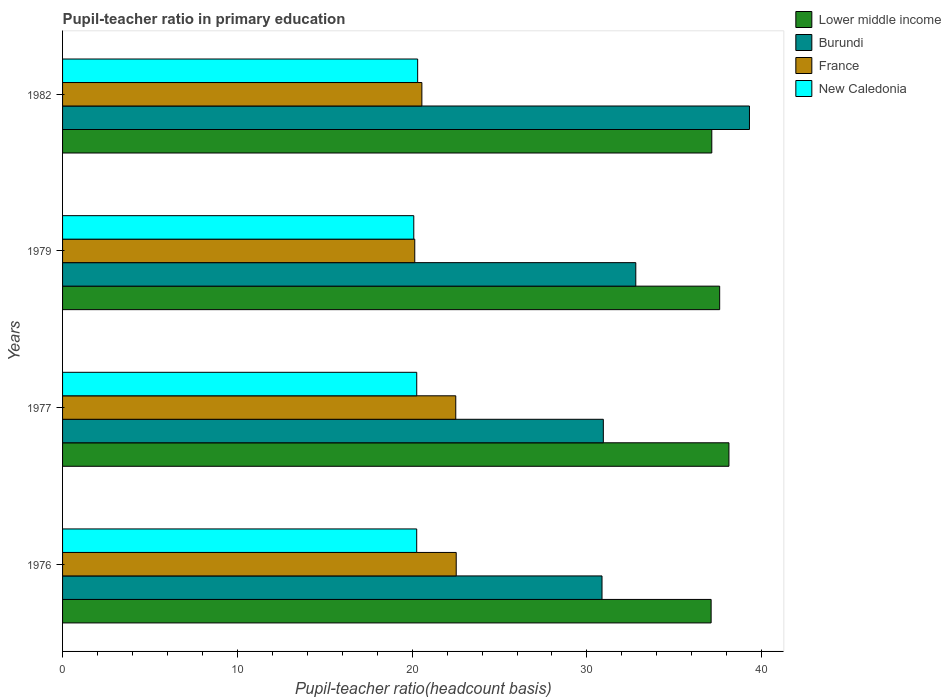How many different coloured bars are there?
Your answer should be very brief. 4. How many groups of bars are there?
Give a very brief answer. 4. Are the number of bars per tick equal to the number of legend labels?
Offer a terse response. Yes. How many bars are there on the 1st tick from the top?
Offer a terse response. 4. How many bars are there on the 4th tick from the bottom?
Offer a terse response. 4. In how many cases, is the number of bars for a given year not equal to the number of legend labels?
Keep it short and to the point. 0. What is the pupil-teacher ratio in primary education in France in 1979?
Your response must be concise. 20.15. Across all years, what is the maximum pupil-teacher ratio in primary education in Burundi?
Provide a short and direct response. 39.3. Across all years, what is the minimum pupil-teacher ratio in primary education in Lower middle income?
Keep it short and to the point. 37.11. In which year was the pupil-teacher ratio in primary education in New Caledonia maximum?
Your response must be concise. 1982. In which year was the pupil-teacher ratio in primary education in Lower middle income minimum?
Provide a short and direct response. 1976. What is the total pupil-teacher ratio in primary education in Lower middle income in the graph?
Provide a succinct answer. 149.97. What is the difference between the pupil-teacher ratio in primary education in Burundi in 1979 and that in 1982?
Make the answer very short. -6.5. What is the difference between the pupil-teacher ratio in primary education in New Caledonia in 1977 and the pupil-teacher ratio in primary education in Burundi in 1982?
Your answer should be compact. -19.04. What is the average pupil-teacher ratio in primary education in New Caledonia per year?
Your answer should be compact. 20.23. In the year 1977, what is the difference between the pupil-teacher ratio in primary education in Burundi and pupil-teacher ratio in primary education in France?
Your answer should be very brief. 8.44. In how many years, is the pupil-teacher ratio in primary education in France greater than 4 ?
Provide a short and direct response. 4. What is the ratio of the pupil-teacher ratio in primary education in Burundi in 1976 to that in 1979?
Your answer should be very brief. 0.94. Is the pupil-teacher ratio in primary education in Burundi in 1977 less than that in 1982?
Offer a very short reply. Yes. Is the difference between the pupil-teacher ratio in primary education in Burundi in 1976 and 1977 greater than the difference between the pupil-teacher ratio in primary education in France in 1976 and 1977?
Your answer should be compact. No. What is the difference between the highest and the second highest pupil-teacher ratio in primary education in Burundi?
Your response must be concise. 6.5. What is the difference between the highest and the lowest pupil-teacher ratio in primary education in Lower middle income?
Your answer should be compact. 1.02. In how many years, is the pupil-teacher ratio in primary education in Lower middle income greater than the average pupil-teacher ratio in primary education in Lower middle income taken over all years?
Provide a succinct answer. 2. What does the 4th bar from the top in 1982 represents?
Your answer should be very brief. Lower middle income. What does the 4th bar from the bottom in 1977 represents?
Keep it short and to the point. New Caledonia. Are all the bars in the graph horizontal?
Give a very brief answer. Yes. What is the difference between two consecutive major ticks on the X-axis?
Provide a succinct answer. 10. Are the values on the major ticks of X-axis written in scientific E-notation?
Offer a terse response. No. Does the graph contain grids?
Provide a succinct answer. No. Where does the legend appear in the graph?
Make the answer very short. Top right. How are the legend labels stacked?
Offer a very short reply. Vertical. What is the title of the graph?
Your answer should be compact. Pupil-teacher ratio in primary education. What is the label or title of the X-axis?
Give a very brief answer. Pupil-teacher ratio(headcount basis). What is the Pupil-teacher ratio(headcount basis) in Lower middle income in 1976?
Ensure brevity in your answer.  37.11. What is the Pupil-teacher ratio(headcount basis) in Burundi in 1976?
Offer a terse response. 30.86. What is the Pupil-teacher ratio(headcount basis) in France in 1976?
Your response must be concise. 22.52. What is the Pupil-teacher ratio(headcount basis) of New Caledonia in 1976?
Your response must be concise. 20.26. What is the Pupil-teacher ratio(headcount basis) of Lower middle income in 1977?
Your answer should be very brief. 38.13. What is the Pupil-teacher ratio(headcount basis) in Burundi in 1977?
Offer a very short reply. 30.94. What is the Pupil-teacher ratio(headcount basis) of France in 1977?
Your answer should be compact. 22.5. What is the Pupil-teacher ratio(headcount basis) of New Caledonia in 1977?
Ensure brevity in your answer.  20.26. What is the Pupil-teacher ratio(headcount basis) of Lower middle income in 1979?
Provide a succinct answer. 37.6. What is the Pupil-teacher ratio(headcount basis) in Burundi in 1979?
Give a very brief answer. 32.8. What is the Pupil-teacher ratio(headcount basis) in France in 1979?
Your response must be concise. 20.15. What is the Pupil-teacher ratio(headcount basis) of New Caledonia in 1979?
Provide a succinct answer. 20.09. What is the Pupil-teacher ratio(headcount basis) of Lower middle income in 1982?
Keep it short and to the point. 37.14. What is the Pupil-teacher ratio(headcount basis) in Burundi in 1982?
Your answer should be very brief. 39.3. What is the Pupil-teacher ratio(headcount basis) of France in 1982?
Keep it short and to the point. 20.56. What is the Pupil-teacher ratio(headcount basis) of New Caledonia in 1982?
Give a very brief answer. 20.32. Across all years, what is the maximum Pupil-teacher ratio(headcount basis) of Lower middle income?
Offer a very short reply. 38.13. Across all years, what is the maximum Pupil-teacher ratio(headcount basis) of Burundi?
Make the answer very short. 39.3. Across all years, what is the maximum Pupil-teacher ratio(headcount basis) of France?
Provide a short and direct response. 22.52. Across all years, what is the maximum Pupil-teacher ratio(headcount basis) of New Caledonia?
Your answer should be compact. 20.32. Across all years, what is the minimum Pupil-teacher ratio(headcount basis) of Lower middle income?
Provide a short and direct response. 37.11. Across all years, what is the minimum Pupil-teacher ratio(headcount basis) in Burundi?
Your response must be concise. 30.86. Across all years, what is the minimum Pupil-teacher ratio(headcount basis) in France?
Offer a terse response. 20.15. Across all years, what is the minimum Pupil-teacher ratio(headcount basis) of New Caledonia?
Your answer should be compact. 20.09. What is the total Pupil-teacher ratio(headcount basis) of Lower middle income in the graph?
Make the answer very short. 149.97. What is the total Pupil-teacher ratio(headcount basis) in Burundi in the graph?
Provide a short and direct response. 133.9. What is the total Pupil-teacher ratio(headcount basis) in France in the graph?
Provide a short and direct response. 85.73. What is the total Pupil-teacher ratio(headcount basis) of New Caledonia in the graph?
Provide a short and direct response. 80.94. What is the difference between the Pupil-teacher ratio(headcount basis) of Lower middle income in 1976 and that in 1977?
Provide a short and direct response. -1.02. What is the difference between the Pupil-teacher ratio(headcount basis) in Burundi in 1976 and that in 1977?
Your response must be concise. -0.08. What is the difference between the Pupil-teacher ratio(headcount basis) in France in 1976 and that in 1977?
Make the answer very short. 0.03. What is the difference between the Pupil-teacher ratio(headcount basis) in New Caledonia in 1976 and that in 1977?
Ensure brevity in your answer.  -0. What is the difference between the Pupil-teacher ratio(headcount basis) in Lower middle income in 1976 and that in 1979?
Keep it short and to the point. -0.49. What is the difference between the Pupil-teacher ratio(headcount basis) of Burundi in 1976 and that in 1979?
Your answer should be very brief. -1.93. What is the difference between the Pupil-teacher ratio(headcount basis) of France in 1976 and that in 1979?
Offer a terse response. 2.37. What is the difference between the Pupil-teacher ratio(headcount basis) of New Caledonia in 1976 and that in 1979?
Give a very brief answer. 0.17. What is the difference between the Pupil-teacher ratio(headcount basis) in Lower middle income in 1976 and that in 1982?
Provide a succinct answer. -0.04. What is the difference between the Pupil-teacher ratio(headcount basis) of Burundi in 1976 and that in 1982?
Offer a terse response. -8.44. What is the difference between the Pupil-teacher ratio(headcount basis) in France in 1976 and that in 1982?
Your answer should be compact. 1.96. What is the difference between the Pupil-teacher ratio(headcount basis) in New Caledonia in 1976 and that in 1982?
Offer a very short reply. -0.05. What is the difference between the Pupil-teacher ratio(headcount basis) in Lower middle income in 1977 and that in 1979?
Keep it short and to the point. 0.53. What is the difference between the Pupil-teacher ratio(headcount basis) in Burundi in 1977 and that in 1979?
Provide a short and direct response. -1.86. What is the difference between the Pupil-teacher ratio(headcount basis) in France in 1977 and that in 1979?
Make the answer very short. 2.35. What is the difference between the Pupil-teacher ratio(headcount basis) of New Caledonia in 1977 and that in 1979?
Offer a very short reply. 0.17. What is the difference between the Pupil-teacher ratio(headcount basis) of Lower middle income in 1977 and that in 1982?
Make the answer very short. 0.98. What is the difference between the Pupil-teacher ratio(headcount basis) of Burundi in 1977 and that in 1982?
Ensure brevity in your answer.  -8.36. What is the difference between the Pupil-teacher ratio(headcount basis) of France in 1977 and that in 1982?
Keep it short and to the point. 1.94. What is the difference between the Pupil-teacher ratio(headcount basis) in New Caledonia in 1977 and that in 1982?
Offer a terse response. -0.05. What is the difference between the Pupil-teacher ratio(headcount basis) of Lower middle income in 1979 and that in 1982?
Offer a terse response. 0.45. What is the difference between the Pupil-teacher ratio(headcount basis) in Burundi in 1979 and that in 1982?
Give a very brief answer. -6.5. What is the difference between the Pupil-teacher ratio(headcount basis) of France in 1979 and that in 1982?
Keep it short and to the point. -0.41. What is the difference between the Pupil-teacher ratio(headcount basis) of New Caledonia in 1979 and that in 1982?
Offer a terse response. -0.22. What is the difference between the Pupil-teacher ratio(headcount basis) in Lower middle income in 1976 and the Pupil-teacher ratio(headcount basis) in Burundi in 1977?
Offer a very short reply. 6.17. What is the difference between the Pupil-teacher ratio(headcount basis) of Lower middle income in 1976 and the Pupil-teacher ratio(headcount basis) of France in 1977?
Provide a short and direct response. 14.61. What is the difference between the Pupil-teacher ratio(headcount basis) of Lower middle income in 1976 and the Pupil-teacher ratio(headcount basis) of New Caledonia in 1977?
Keep it short and to the point. 16.84. What is the difference between the Pupil-teacher ratio(headcount basis) of Burundi in 1976 and the Pupil-teacher ratio(headcount basis) of France in 1977?
Your answer should be very brief. 8.37. What is the difference between the Pupil-teacher ratio(headcount basis) of Burundi in 1976 and the Pupil-teacher ratio(headcount basis) of New Caledonia in 1977?
Your answer should be compact. 10.6. What is the difference between the Pupil-teacher ratio(headcount basis) in France in 1976 and the Pupil-teacher ratio(headcount basis) in New Caledonia in 1977?
Keep it short and to the point. 2.26. What is the difference between the Pupil-teacher ratio(headcount basis) of Lower middle income in 1976 and the Pupil-teacher ratio(headcount basis) of Burundi in 1979?
Make the answer very short. 4.31. What is the difference between the Pupil-teacher ratio(headcount basis) of Lower middle income in 1976 and the Pupil-teacher ratio(headcount basis) of France in 1979?
Ensure brevity in your answer.  16.96. What is the difference between the Pupil-teacher ratio(headcount basis) in Lower middle income in 1976 and the Pupil-teacher ratio(headcount basis) in New Caledonia in 1979?
Your answer should be very brief. 17.01. What is the difference between the Pupil-teacher ratio(headcount basis) in Burundi in 1976 and the Pupil-teacher ratio(headcount basis) in France in 1979?
Offer a very short reply. 10.71. What is the difference between the Pupil-teacher ratio(headcount basis) in Burundi in 1976 and the Pupil-teacher ratio(headcount basis) in New Caledonia in 1979?
Ensure brevity in your answer.  10.77. What is the difference between the Pupil-teacher ratio(headcount basis) in France in 1976 and the Pupil-teacher ratio(headcount basis) in New Caledonia in 1979?
Your response must be concise. 2.43. What is the difference between the Pupil-teacher ratio(headcount basis) in Lower middle income in 1976 and the Pupil-teacher ratio(headcount basis) in Burundi in 1982?
Your answer should be very brief. -2.19. What is the difference between the Pupil-teacher ratio(headcount basis) in Lower middle income in 1976 and the Pupil-teacher ratio(headcount basis) in France in 1982?
Ensure brevity in your answer.  16.55. What is the difference between the Pupil-teacher ratio(headcount basis) in Lower middle income in 1976 and the Pupil-teacher ratio(headcount basis) in New Caledonia in 1982?
Offer a terse response. 16.79. What is the difference between the Pupil-teacher ratio(headcount basis) in Burundi in 1976 and the Pupil-teacher ratio(headcount basis) in France in 1982?
Offer a very short reply. 10.31. What is the difference between the Pupil-teacher ratio(headcount basis) in Burundi in 1976 and the Pupil-teacher ratio(headcount basis) in New Caledonia in 1982?
Provide a short and direct response. 10.55. What is the difference between the Pupil-teacher ratio(headcount basis) of France in 1976 and the Pupil-teacher ratio(headcount basis) of New Caledonia in 1982?
Offer a very short reply. 2.21. What is the difference between the Pupil-teacher ratio(headcount basis) of Lower middle income in 1977 and the Pupil-teacher ratio(headcount basis) of Burundi in 1979?
Make the answer very short. 5.33. What is the difference between the Pupil-teacher ratio(headcount basis) in Lower middle income in 1977 and the Pupil-teacher ratio(headcount basis) in France in 1979?
Offer a very short reply. 17.97. What is the difference between the Pupil-teacher ratio(headcount basis) in Lower middle income in 1977 and the Pupil-teacher ratio(headcount basis) in New Caledonia in 1979?
Provide a short and direct response. 18.03. What is the difference between the Pupil-teacher ratio(headcount basis) of Burundi in 1977 and the Pupil-teacher ratio(headcount basis) of France in 1979?
Your response must be concise. 10.79. What is the difference between the Pupil-teacher ratio(headcount basis) of Burundi in 1977 and the Pupil-teacher ratio(headcount basis) of New Caledonia in 1979?
Make the answer very short. 10.85. What is the difference between the Pupil-teacher ratio(headcount basis) of France in 1977 and the Pupil-teacher ratio(headcount basis) of New Caledonia in 1979?
Provide a short and direct response. 2.4. What is the difference between the Pupil-teacher ratio(headcount basis) in Lower middle income in 1977 and the Pupil-teacher ratio(headcount basis) in Burundi in 1982?
Provide a succinct answer. -1.18. What is the difference between the Pupil-teacher ratio(headcount basis) of Lower middle income in 1977 and the Pupil-teacher ratio(headcount basis) of France in 1982?
Your answer should be very brief. 17.57. What is the difference between the Pupil-teacher ratio(headcount basis) in Lower middle income in 1977 and the Pupil-teacher ratio(headcount basis) in New Caledonia in 1982?
Provide a succinct answer. 17.81. What is the difference between the Pupil-teacher ratio(headcount basis) in Burundi in 1977 and the Pupil-teacher ratio(headcount basis) in France in 1982?
Make the answer very short. 10.38. What is the difference between the Pupil-teacher ratio(headcount basis) of Burundi in 1977 and the Pupil-teacher ratio(headcount basis) of New Caledonia in 1982?
Provide a short and direct response. 10.62. What is the difference between the Pupil-teacher ratio(headcount basis) in France in 1977 and the Pupil-teacher ratio(headcount basis) in New Caledonia in 1982?
Give a very brief answer. 2.18. What is the difference between the Pupil-teacher ratio(headcount basis) of Lower middle income in 1979 and the Pupil-teacher ratio(headcount basis) of Burundi in 1982?
Keep it short and to the point. -1.7. What is the difference between the Pupil-teacher ratio(headcount basis) in Lower middle income in 1979 and the Pupil-teacher ratio(headcount basis) in France in 1982?
Provide a short and direct response. 17.04. What is the difference between the Pupil-teacher ratio(headcount basis) of Lower middle income in 1979 and the Pupil-teacher ratio(headcount basis) of New Caledonia in 1982?
Offer a terse response. 17.28. What is the difference between the Pupil-teacher ratio(headcount basis) in Burundi in 1979 and the Pupil-teacher ratio(headcount basis) in France in 1982?
Your answer should be compact. 12.24. What is the difference between the Pupil-teacher ratio(headcount basis) of Burundi in 1979 and the Pupil-teacher ratio(headcount basis) of New Caledonia in 1982?
Keep it short and to the point. 12.48. What is the difference between the Pupil-teacher ratio(headcount basis) of France in 1979 and the Pupil-teacher ratio(headcount basis) of New Caledonia in 1982?
Your response must be concise. -0.17. What is the average Pupil-teacher ratio(headcount basis) in Lower middle income per year?
Your answer should be very brief. 37.49. What is the average Pupil-teacher ratio(headcount basis) in Burundi per year?
Your answer should be compact. 33.48. What is the average Pupil-teacher ratio(headcount basis) in France per year?
Provide a succinct answer. 21.43. What is the average Pupil-teacher ratio(headcount basis) of New Caledonia per year?
Give a very brief answer. 20.23. In the year 1976, what is the difference between the Pupil-teacher ratio(headcount basis) of Lower middle income and Pupil-teacher ratio(headcount basis) of Burundi?
Offer a terse response. 6.24. In the year 1976, what is the difference between the Pupil-teacher ratio(headcount basis) in Lower middle income and Pupil-teacher ratio(headcount basis) in France?
Your response must be concise. 14.58. In the year 1976, what is the difference between the Pupil-teacher ratio(headcount basis) of Lower middle income and Pupil-teacher ratio(headcount basis) of New Caledonia?
Keep it short and to the point. 16.85. In the year 1976, what is the difference between the Pupil-teacher ratio(headcount basis) of Burundi and Pupil-teacher ratio(headcount basis) of France?
Offer a terse response. 8.34. In the year 1976, what is the difference between the Pupil-teacher ratio(headcount basis) of Burundi and Pupil-teacher ratio(headcount basis) of New Caledonia?
Offer a very short reply. 10.6. In the year 1976, what is the difference between the Pupil-teacher ratio(headcount basis) in France and Pupil-teacher ratio(headcount basis) in New Caledonia?
Keep it short and to the point. 2.26. In the year 1977, what is the difference between the Pupil-teacher ratio(headcount basis) in Lower middle income and Pupil-teacher ratio(headcount basis) in Burundi?
Make the answer very short. 7.19. In the year 1977, what is the difference between the Pupil-teacher ratio(headcount basis) in Lower middle income and Pupil-teacher ratio(headcount basis) in France?
Keep it short and to the point. 15.63. In the year 1977, what is the difference between the Pupil-teacher ratio(headcount basis) in Lower middle income and Pupil-teacher ratio(headcount basis) in New Caledonia?
Provide a succinct answer. 17.86. In the year 1977, what is the difference between the Pupil-teacher ratio(headcount basis) of Burundi and Pupil-teacher ratio(headcount basis) of France?
Your response must be concise. 8.44. In the year 1977, what is the difference between the Pupil-teacher ratio(headcount basis) in Burundi and Pupil-teacher ratio(headcount basis) in New Caledonia?
Keep it short and to the point. 10.68. In the year 1977, what is the difference between the Pupil-teacher ratio(headcount basis) of France and Pupil-teacher ratio(headcount basis) of New Caledonia?
Keep it short and to the point. 2.23. In the year 1979, what is the difference between the Pupil-teacher ratio(headcount basis) of Lower middle income and Pupil-teacher ratio(headcount basis) of Burundi?
Your response must be concise. 4.8. In the year 1979, what is the difference between the Pupil-teacher ratio(headcount basis) of Lower middle income and Pupil-teacher ratio(headcount basis) of France?
Give a very brief answer. 17.44. In the year 1979, what is the difference between the Pupil-teacher ratio(headcount basis) of Lower middle income and Pupil-teacher ratio(headcount basis) of New Caledonia?
Your answer should be very brief. 17.5. In the year 1979, what is the difference between the Pupil-teacher ratio(headcount basis) of Burundi and Pupil-teacher ratio(headcount basis) of France?
Provide a short and direct response. 12.65. In the year 1979, what is the difference between the Pupil-teacher ratio(headcount basis) in Burundi and Pupil-teacher ratio(headcount basis) in New Caledonia?
Ensure brevity in your answer.  12.7. In the year 1979, what is the difference between the Pupil-teacher ratio(headcount basis) in France and Pupil-teacher ratio(headcount basis) in New Caledonia?
Your answer should be compact. 0.06. In the year 1982, what is the difference between the Pupil-teacher ratio(headcount basis) of Lower middle income and Pupil-teacher ratio(headcount basis) of Burundi?
Make the answer very short. -2.16. In the year 1982, what is the difference between the Pupil-teacher ratio(headcount basis) in Lower middle income and Pupil-teacher ratio(headcount basis) in France?
Offer a very short reply. 16.59. In the year 1982, what is the difference between the Pupil-teacher ratio(headcount basis) of Lower middle income and Pupil-teacher ratio(headcount basis) of New Caledonia?
Your response must be concise. 16.83. In the year 1982, what is the difference between the Pupil-teacher ratio(headcount basis) of Burundi and Pupil-teacher ratio(headcount basis) of France?
Provide a succinct answer. 18.74. In the year 1982, what is the difference between the Pupil-teacher ratio(headcount basis) of Burundi and Pupil-teacher ratio(headcount basis) of New Caledonia?
Provide a short and direct response. 18.98. In the year 1982, what is the difference between the Pupil-teacher ratio(headcount basis) in France and Pupil-teacher ratio(headcount basis) in New Caledonia?
Offer a very short reply. 0.24. What is the ratio of the Pupil-teacher ratio(headcount basis) in Lower middle income in 1976 to that in 1977?
Keep it short and to the point. 0.97. What is the ratio of the Pupil-teacher ratio(headcount basis) of Burundi in 1976 to that in 1977?
Ensure brevity in your answer.  1. What is the ratio of the Pupil-teacher ratio(headcount basis) of Lower middle income in 1976 to that in 1979?
Ensure brevity in your answer.  0.99. What is the ratio of the Pupil-teacher ratio(headcount basis) in Burundi in 1976 to that in 1979?
Make the answer very short. 0.94. What is the ratio of the Pupil-teacher ratio(headcount basis) of France in 1976 to that in 1979?
Provide a succinct answer. 1.12. What is the ratio of the Pupil-teacher ratio(headcount basis) of New Caledonia in 1976 to that in 1979?
Provide a succinct answer. 1.01. What is the ratio of the Pupil-teacher ratio(headcount basis) of Lower middle income in 1976 to that in 1982?
Your answer should be very brief. 1. What is the ratio of the Pupil-teacher ratio(headcount basis) of Burundi in 1976 to that in 1982?
Your answer should be compact. 0.79. What is the ratio of the Pupil-teacher ratio(headcount basis) in France in 1976 to that in 1982?
Your answer should be very brief. 1.1. What is the ratio of the Pupil-teacher ratio(headcount basis) in New Caledonia in 1976 to that in 1982?
Your answer should be very brief. 1. What is the ratio of the Pupil-teacher ratio(headcount basis) of Lower middle income in 1977 to that in 1979?
Offer a very short reply. 1.01. What is the ratio of the Pupil-teacher ratio(headcount basis) of Burundi in 1977 to that in 1979?
Provide a succinct answer. 0.94. What is the ratio of the Pupil-teacher ratio(headcount basis) in France in 1977 to that in 1979?
Your response must be concise. 1.12. What is the ratio of the Pupil-teacher ratio(headcount basis) in New Caledonia in 1977 to that in 1979?
Your answer should be very brief. 1.01. What is the ratio of the Pupil-teacher ratio(headcount basis) of Lower middle income in 1977 to that in 1982?
Your answer should be compact. 1.03. What is the ratio of the Pupil-teacher ratio(headcount basis) of Burundi in 1977 to that in 1982?
Offer a very short reply. 0.79. What is the ratio of the Pupil-teacher ratio(headcount basis) of France in 1977 to that in 1982?
Make the answer very short. 1.09. What is the ratio of the Pupil-teacher ratio(headcount basis) of New Caledonia in 1977 to that in 1982?
Provide a short and direct response. 1. What is the ratio of the Pupil-teacher ratio(headcount basis) in Lower middle income in 1979 to that in 1982?
Provide a short and direct response. 1.01. What is the ratio of the Pupil-teacher ratio(headcount basis) of Burundi in 1979 to that in 1982?
Provide a short and direct response. 0.83. What is the ratio of the Pupil-teacher ratio(headcount basis) of France in 1979 to that in 1982?
Provide a succinct answer. 0.98. What is the ratio of the Pupil-teacher ratio(headcount basis) of New Caledonia in 1979 to that in 1982?
Keep it short and to the point. 0.99. What is the difference between the highest and the second highest Pupil-teacher ratio(headcount basis) of Lower middle income?
Keep it short and to the point. 0.53. What is the difference between the highest and the second highest Pupil-teacher ratio(headcount basis) in Burundi?
Your answer should be very brief. 6.5. What is the difference between the highest and the second highest Pupil-teacher ratio(headcount basis) in France?
Your answer should be very brief. 0.03. What is the difference between the highest and the second highest Pupil-teacher ratio(headcount basis) in New Caledonia?
Make the answer very short. 0.05. What is the difference between the highest and the lowest Pupil-teacher ratio(headcount basis) of Lower middle income?
Offer a very short reply. 1.02. What is the difference between the highest and the lowest Pupil-teacher ratio(headcount basis) in Burundi?
Ensure brevity in your answer.  8.44. What is the difference between the highest and the lowest Pupil-teacher ratio(headcount basis) in France?
Give a very brief answer. 2.37. What is the difference between the highest and the lowest Pupil-teacher ratio(headcount basis) in New Caledonia?
Keep it short and to the point. 0.22. 